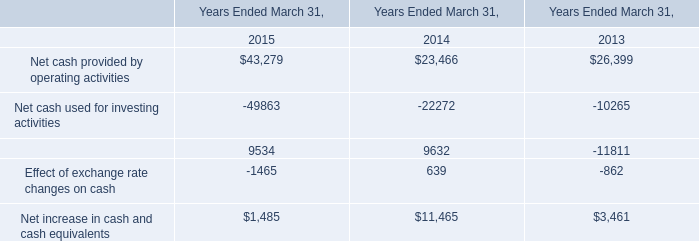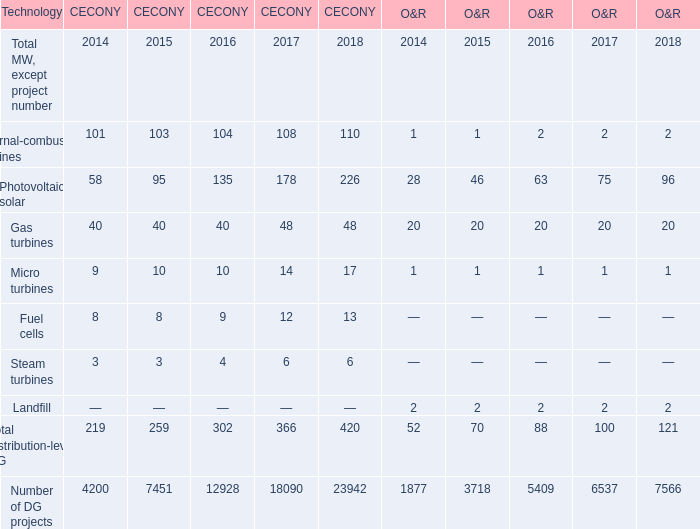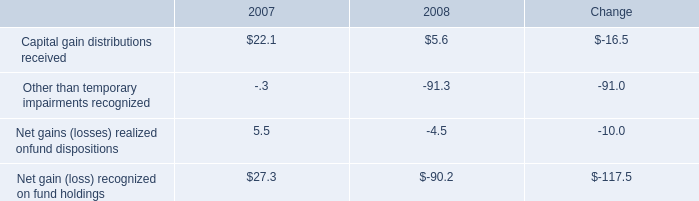what percentage of tangible book value is made up of cash and cash equivalents and mutual fund investment holdings at december 31 , 2009? 
Computations: (1.4 / 2.2)
Answer: 0.63636. 